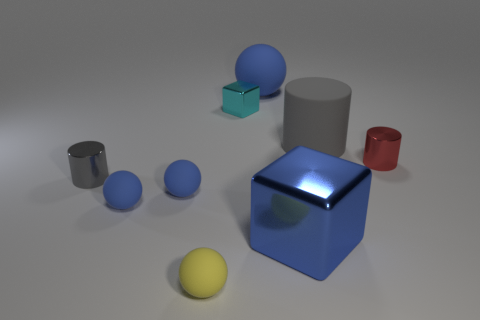What is the material of the tiny thing that is the same shape as the large blue shiny thing?
Keep it short and to the point. Metal. Are there any other things that have the same color as the tiny block?
Offer a very short reply. No. There is a red cylinder that is the same size as the yellow object; what is it made of?
Provide a succinct answer. Metal. Are there any small blue things made of the same material as the small red cylinder?
Offer a terse response. No. There is a gray thing that is behind the cylinder that is on the left side of the large matte thing to the left of the blue shiny block; what shape is it?
Give a very brief answer. Cylinder. Does the yellow thing have the same size as the ball that is right of the tiny yellow rubber thing?
Your answer should be compact. No. There is a tiny metal object that is in front of the rubber cylinder and on the right side of the yellow rubber object; what shape is it?
Ensure brevity in your answer.  Cylinder. What number of small objects are red metallic objects or blue shiny cubes?
Provide a short and direct response. 1. Are there an equal number of large blue things that are left of the yellow ball and large gray objects that are in front of the large gray cylinder?
Make the answer very short. Yes. What number of other objects are there of the same color as the tiny shiny block?
Offer a terse response. 0. 